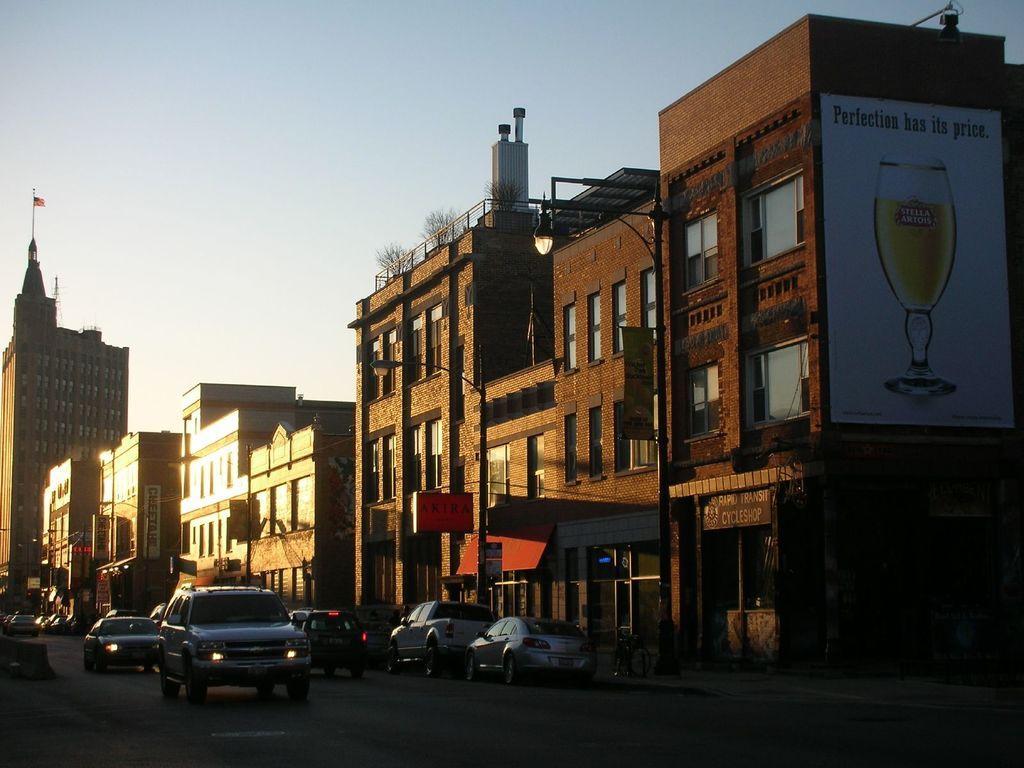In one or two sentences, can you explain what this image depicts? In this image we can see few buildings, vehicles on the road, street lights, plants and a flag on the building and boards attached to the buildings and the sky in the background. 